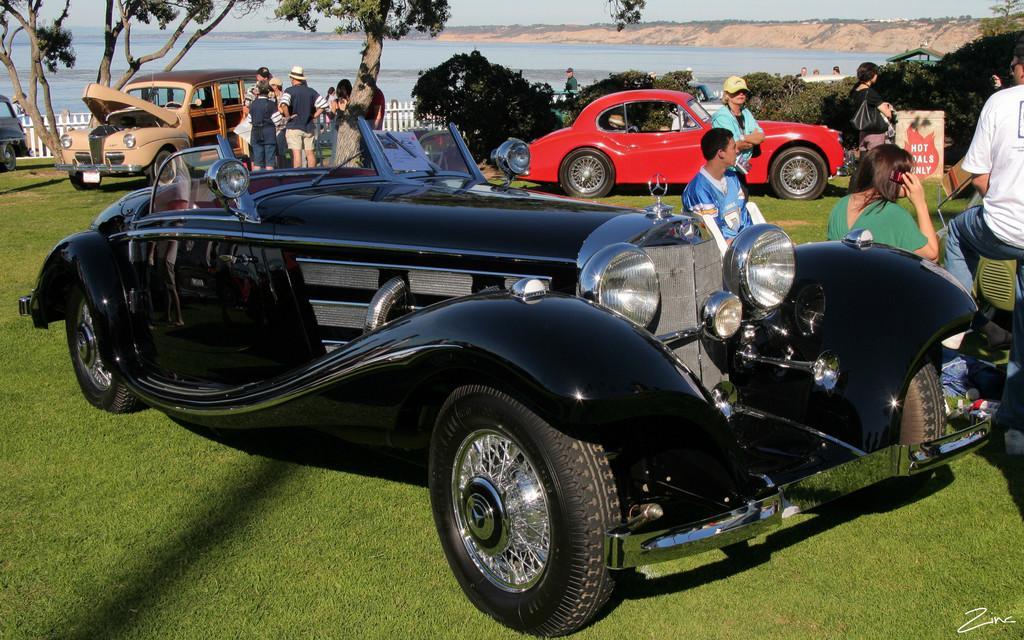In one or two sentences, can you explain what this image depicts? In the image there are different types of cars kept in a garden and around the cars there are few people, in the background there are trees, plants and a water surface, around the water surface there is a small mountain. 